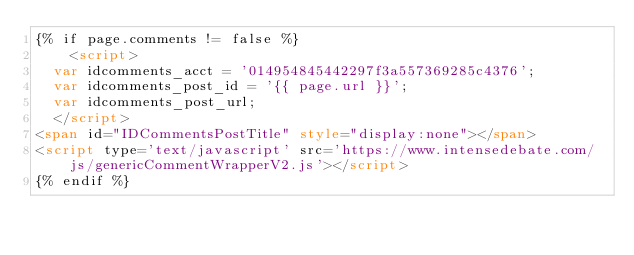<code> <loc_0><loc_0><loc_500><loc_500><_HTML_>{% if page.comments != false %}
    <script>
	var idcomments_acct = '014954845442297f3a557369285c4376';
	var idcomments_post_id = '{{ page.url }}';
	var idcomments_post_url;
	</script>
<span id="IDCommentsPostTitle" style="display:none"></span>
<script type='text/javascript' src='https://www.intensedebate.com/js/genericCommentWrapperV2.js'></script>
{% endif %}</code> 